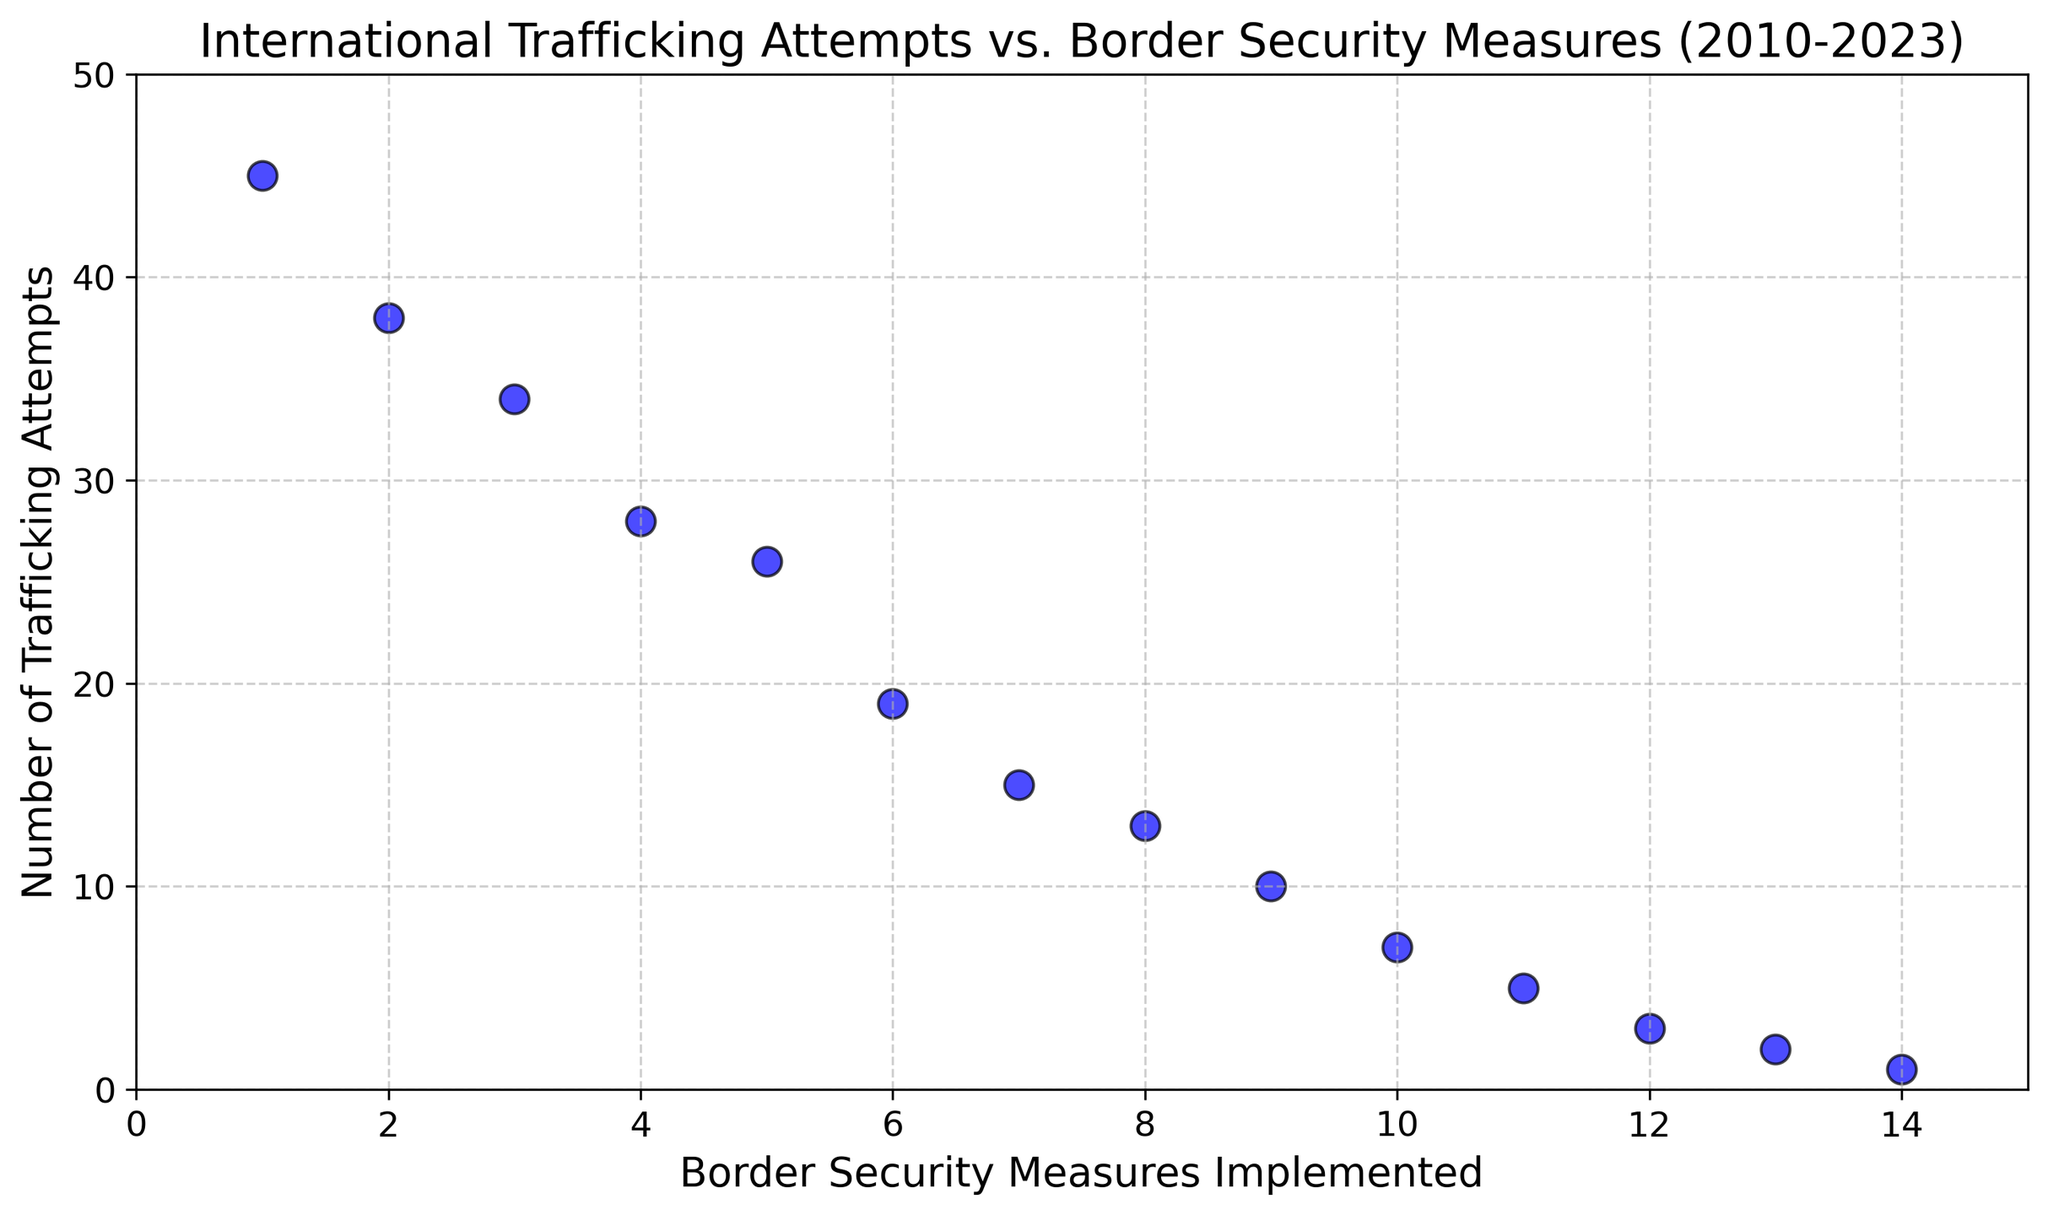What trend is observed in the number of trafficking attempts as border security measures increase? As the border security measures increase, the number of trafficking attempts decreases consistently over the years. This is evident from the scatter plot where the points trend downward as you move to the right along the x-axis.
Answer: Decreasing In which year were the fewest trafficking attempts made? To find the year with the fewest trafficking attempts, identify the lowest point on the y-axis and check the corresponding year. The lowest y-value is 1, occurring in 2023.
Answer: 2023 How many trafficking attempts were recorded when 5 border security measures were implemented? Locate the x-axis (border security measures) value of 5, then find the corresponding y-axis value (trafficking attempts). The plot shows that the number of attempts was 26 for 5 measures.
Answer: 26 What is the difference in trafficking attempts between the years 2010 and 2023? In 2010, there were 45 trafficking attempts, whereas in 2023, there was only 1 attempt. The difference is calculated as 45 - 1 = 44.
Answer: 44 When border security measures increased from 1 to 14, how much did the trafficking attempts decrease on average per year? The number of trafficking attempts decreased from 45 in 2010 to 1 in 2023. The total decrease is 45 - 1 = 44 attempts over 13 years. The average yearly decrease is 44 / 13 ≈ 3.38 attempts per year.
Answer: Approximately 3.38 attempts per year Which range of border security measures corresponds to fewer than 10 trafficking attempts? Identify all points on the plot where the y-axis value (trafficking attempts) is less than 10. This occurs from the x-axis value (border security measures) of 9 onwards. So, measures 9 to 14 correspond to fewer than 10 attempts.
Answer: 9 to 14 Between which two consecutive years was the largest decrease in trafficking attempts observed? To identify the largest decrease, inspect the vertical distance between consecutive points. The largest decrease is between 2014 (26 attempts) and 2015 (19 attempts), a reduction of 26 - 19 = 7 attempts.
Answer: 2014 to 2015 What is the median number of trafficking attempts over the period shown? Arrange the number of trafficking attempts in ascending order: [1, 2, 3, 5, 7, 10, 13, 15, 19, 26, 28, 34, 38, 45]. For 14 values, the median is the average of the 7th and 8th values: (13 + 15) / 2 = 14.
Answer: 14 How does the plot indicate the strength of the relationship between border security measures and trafficking attempts? The plot shows a strong negative correlation, as indicated by the steep downward trend from left to right. As border security measures increase, trafficking attempts decrease consistently, suggesting a strong inverse relationship.
Answer: Strong negative correlation Is there any year where an increase in border security did not result in a decrease in trafficking attempts? Inspect the scatter plot and verify if there is any year where the trajectory does not consistently decline. Every increase in border security measures consistently corresponds to a decrease in trafficking attempts, so no such year exists.
Answer: No 